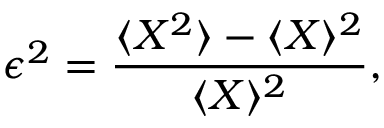<formula> <loc_0><loc_0><loc_500><loc_500>\epsilon ^ { 2 } = \frac { \langle X ^ { 2 } \rangle - \langle X \rangle ^ { 2 } } { \langle X \rangle ^ { 2 } } ,</formula> 